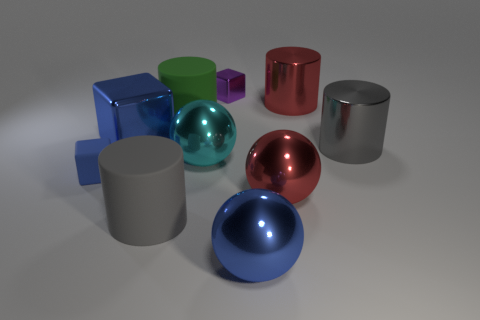Subtract all yellow balls. How many blue blocks are left? 2 Subtract all red cylinders. How many cylinders are left? 3 Subtract 1 cylinders. How many cylinders are left? 3 Subtract all big green rubber cylinders. How many cylinders are left? 3 Subtract all yellow cylinders. Subtract all blue blocks. How many cylinders are left? 4 Subtract all cylinders. How many objects are left? 6 Subtract 2 gray cylinders. How many objects are left? 8 Subtract all large cyan balls. Subtract all big blue metallic balls. How many objects are left? 8 Add 7 small blue cubes. How many small blue cubes are left? 8 Add 2 yellow shiny objects. How many yellow shiny objects exist? 2 